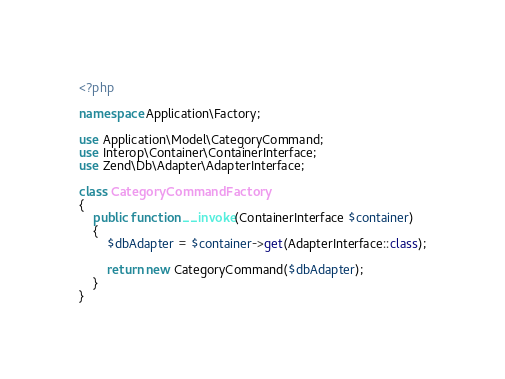Convert code to text. <code><loc_0><loc_0><loc_500><loc_500><_PHP_><?php

namespace Application\Factory;

use Application\Model\CategoryCommand;
use Interop\Container\ContainerInterface;
use Zend\Db\Adapter\AdapterInterface;

class CategoryCommandFactory
{
    public function __invoke(ContainerInterface $container)
    {
        $dbAdapter = $container->get(AdapterInterface::class);

        return new CategoryCommand($dbAdapter);
    }
}
</code> 